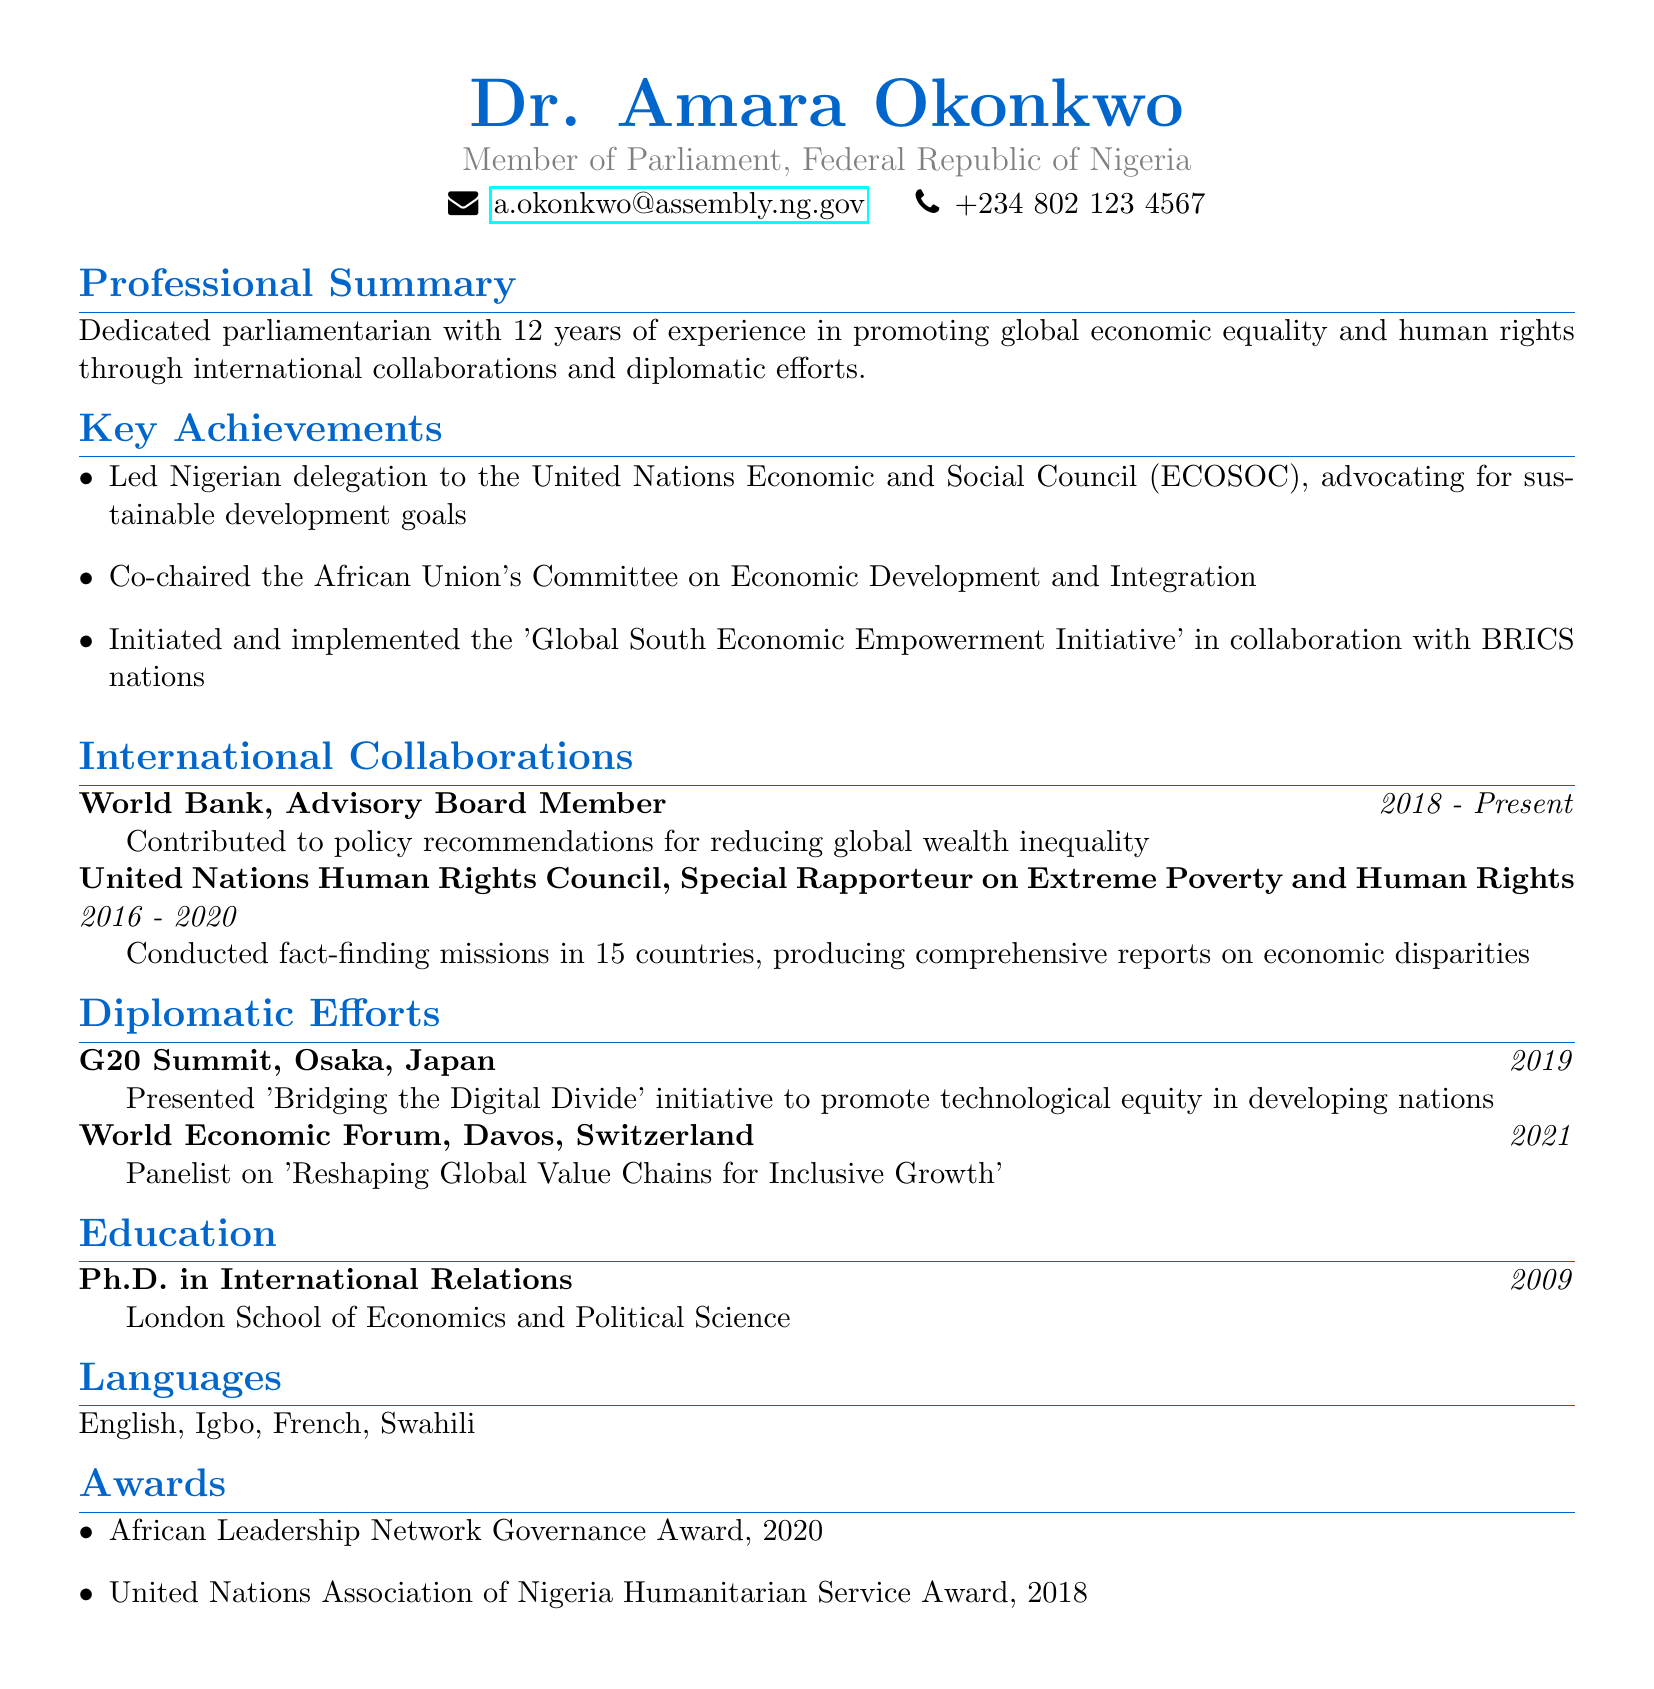What is Dr. Amara Okonkwo’s current position? The document states that Dr. Amara Okonkwo is a Member of Parliament in the Federal Republic of Nigeria.
Answer: Member of Parliament Which organization does Dr. Okonkwo collaborate with as an Advisory Board Member? The World Bank is mentioned as the organization where Dr. Okonkwo serves on the Advisory Board.
Answer: World Bank What initiative did Dr. Okonkwo present at the G20 Summit? The document includes the 'Bridging the Digital Divide' initiative presented by Dr. Okonkwo at the G20 Summit.
Answer: Bridging the Digital Divide In what year did Dr. Okonkwo receive the African Leadership Network Governance Award? The document specifies the year 2020 for the award received by Dr. Okonkwo.
Answer: 2020 How many languages does Dr. Okonkwo speak? The document lists four languages that Dr. Okonkwo speaks.
Answer: Four Who did Dr. Okonkwo co-chair the Committee on Economic Development and Integration with? The African Union is mentioned as the body with which Dr. Okonkwo co-chaired the committee.
Answer: African Union What was Dr. Okonkwo's role from 2016 to 2020? The document identifies Dr. Okonkwo as the Special Rapporteur on Extreme Poverty and Human Rights during that period.
Answer: Special Rapporteur on Extreme Poverty and Human Rights What type of degree does Dr. Okonkwo hold? The document indicates that Dr. Okonkwo holds a Ph.D. in International Relations.
Answer: Ph.D. in International Relations At which event was Dr. Okonkwo a panelist in 2021? The World Economic Forum is stated as the event where Dr. Okonkwo was a panelist.
Answer: World Economic Forum 